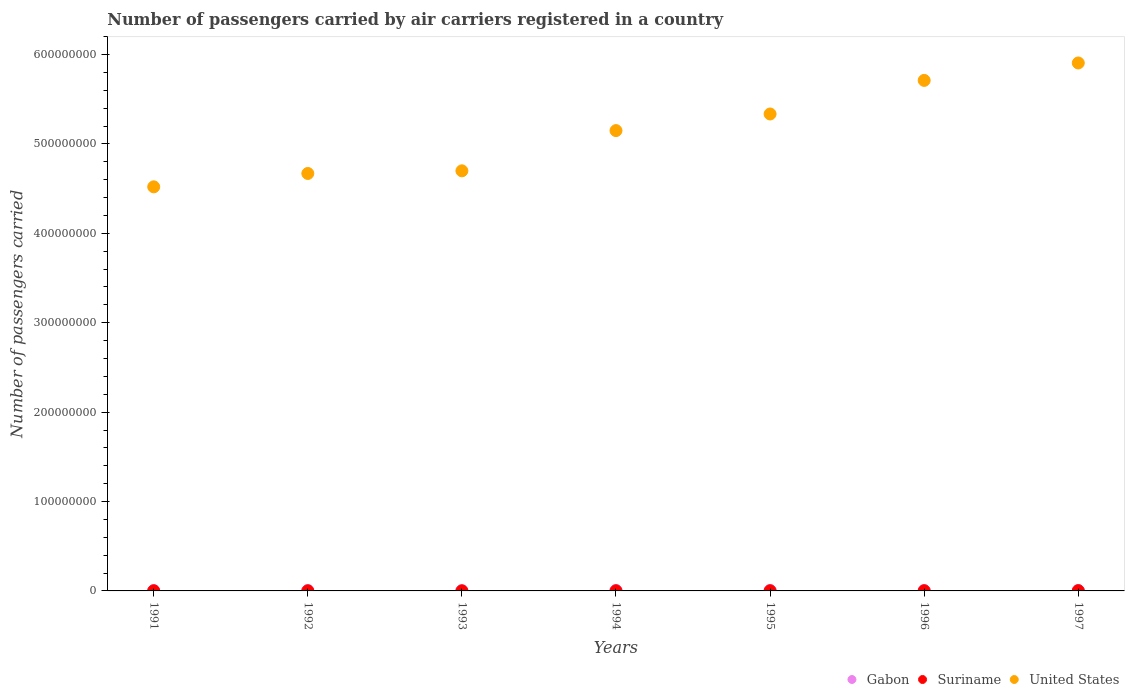Is the number of dotlines equal to the number of legend labels?
Your response must be concise. Yes. Across all years, what is the maximum number of passengers carried by air carriers in Gabon?
Provide a succinct answer. 5.08e+05. Across all years, what is the minimum number of passengers carried by air carriers in Gabon?
Your answer should be very brief. 3.02e+05. In which year was the number of passengers carried by air carriers in United States minimum?
Ensure brevity in your answer.  1991. What is the total number of passengers carried by air carriers in Suriname in the graph?
Your answer should be very brief. 1.15e+06. What is the difference between the number of passengers carried by air carriers in Gabon in 1992 and that in 1993?
Provide a short and direct response. 1.69e+05. What is the difference between the number of passengers carried by air carriers in Suriname in 1993 and the number of passengers carried by air carriers in United States in 1996?
Offer a terse response. -5.71e+08. What is the average number of passengers carried by air carriers in Gabon per year?
Make the answer very short. 4.46e+05. In the year 1996, what is the difference between the number of passengers carried by air carriers in Gabon and number of passengers carried by air carriers in Suriname?
Offer a terse response. 2.37e+05. What is the ratio of the number of passengers carried by air carriers in Suriname in 1991 to that in 1995?
Make the answer very short. 0.93. Is the difference between the number of passengers carried by air carriers in Gabon in 1991 and 1993 greater than the difference between the number of passengers carried by air carriers in Suriname in 1991 and 1993?
Give a very brief answer. Yes. What is the difference between the highest and the second highest number of passengers carried by air carriers in Suriname?
Give a very brief answer. 8.41e+04. What is the difference between the highest and the lowest number of passengers carried by air carriers in Gabon?
Keep it short and to the point. 2.06e+05. In how many years, is the number of passengers carried by air carriers in United States greater than the average number of passengers carried by air carriers in United States taken over all years?
Make the answer very short. 4. How many dotlines are there?
Ensure brevity in your answer.  3. Does the graph contain any zero values?
Ensure brevity in your answer.  No. Where does the legend appear in the graph?
Your answer should be compact. Bottom right. How many legend labels are there?
Your response must be concise. 3. How are the legend labels stacked?
Keep it short and to the point. Horizontal. What is the title of the graph?
Make the answer very short. Number of passengers carried by air carriers registered in a country. What is the label or title of the X-axis?
Ensure brevity in your answer.  Years. What is the label or title of the Y-axis?
Make the answer very short. Number of passengers carried. What is the Number of passengers carried of Gabon in 1991?
Keep it short and to the point. 4.36e+05. What is the Number of passengers carried in United States in 1991?
Make the answer very short. 4.52e+08. What is the Number of passengers carried in Gabon in 1992?
Make the answer very short. 4.71e+05. What is the Number of passengers carried in Suriname in 1992?
Offer a very short reply. 1.23e+05. What is the Number of passengers carried in United States in 1992?
Offer a very short reply. 4.67e+08. What is the Number of passengers carried in Gabon in 1993?
Make the answer very short. 3.02e+05. What is the Number of passengers carried in Suriname in 1993?
Your answer should be very brief. 9.60e+04. What is the Number of passengers carried in United States in 1993?
Provide a succinct answer. 4.70e+08. What is the Number of passengers carried of Gabon in 1994?
Your response must be concise. 5.05e+05. What is the Number of passengers carried in Suriname in 1994?
Ensure brevity in your answer.  1.49e+05. What is the Number of passengers carried of United States in 1994?
Provide a short and direct response. 5.15e+08. What is the Number of passengers carried of Gabon in 1995?
Provide a short and direct response. 5.08e+05. What is the Number of passengers carried in Suriname in 1995?
Ensure brevity in your answer.  1.62e+05. What is the Number of passengers carried of United States in 1995?
Offer a terse response. 5.34e+08. What is the Number of passengers carried of Gabon in 1996?
Keep it short and to the point. 4.31e+05. What is the Number of passengers carried in Suriname in 1996?
Your answer should be very brief. 1.95e+05. What is the Number of passengers carried of United States in 1996?
Your answer should be compact. 5.71e+08. What is the Number of passengers carried of Gabon in 1997?
Offer a very short reply. 4.68e+05. What is the Number of passengers carried of Suriname in 1997?
Offer a very short reply. 2.79e+05. What is the Number of passengers carried of United States in 1997?
Your response must be concise. 5.91e+08. Across all years, what is the maximum Number of passengers carried of Gabon?
Offer a terse response. 5.08e+05. Across all years, what is the maximum Number of passengers carried in Suriname?
Make the answer very short. 2.79e+05. Across all years, what is the maximum Number of passengers carried of United States?
Offer a very short reply. 5.91e+08. Across all years, what is the minimum Number of passengers carried in Gabon?
Offer a terse response. 3.02e+05. Across all years, what is the minimum Number of passengers carried of Suriname?
Provide a short and direct response. 9.60e+04. Across all years, what is the minimum Number of passengers carried in United States?
Offer a very short reply. 4.52e+08. What is the total Number of passengers carried of Gabon in the graph?
Keep it short and to the point. 3.12e+06. What is the total Number of passengers carried of Suriname in the graph?
Give a very brief answer. 1.15e+06. What is the total Number of passengers carried in United States in the graph?
Your response must be concise. 3.60e+09. What is the difference between the Number of passengers carried in Gabon in 1991 and that in 1992?
Keep it short and to the point. -3.54e+04. What is the difference between the Number of passengers carried in Suriname in 1991 and that in 1992?
Provide a short and direct response. 2.70e+04. What is the difference between the Number of passengers carried in United States in 1991 and that in 1992?
Ensure brevity in your answer.  -1.49e+07. What is the difference between the Number of passengers carried of Gabon in 1991 and that in 1993?
Your answer should be compact. 1.34e+05. What is the difference between the Number of passengers carried of Suriname in 1991 and that in 1993?
Provide a short and direct response. 5.40e+04. What is the difference between the Number of passengers carried in United States in 1991 and that in 1993?
Provide a short and direct response. -1.79e+07. What is the difference between the Number of passengers carried in Gabon in 1991 and that in 1994?
Give a very brief answer. -6.92e+04. What is the difference between the Number of passengers carried of Suriname in 1991 and that in 1994?
Your response must be concise. 1100. What is the difference between the Number of passengers carried in United States in 1991 and that in 1994?
Your answer should be very brief. -6.29e+07. What is the difference between the Number of passengers carried in Gabon in 1991 and that in 1995?
Offer a terse response. -7.22e+04. What is the difference between the Number of passengers carried in Suriname in 1991 and that in 1995?
Provide a succinct answer. -1.18e+04. What is the difference between the Number of passengers carried of United States in 1991 and that in 1995?
Make the answer very short. -8.15e+07. What is the difference between the Number of passengers carried of Gabon in 1991 and that in 1996?
Offer a terse response. 4700. What is the difference between the Number of passengers carried of Suriname in 1991 and that in 1996?
Provide a succinct answer. -4.47e+04. What is the difference between the Number of passengers carried in United States in 1991 and that in 1996?
Your answer should be compact. -1.19e+08. What is the difference between the Number of passengers carried of Gabon in 1991 and that in 1997?
Offer a very short reply. -3.25e+04. What is the difference between the Number of passengers carried of Suriname in 1991 and that in 1997?
Your answer should be very brief. -1.29e+05. What is the difference between the Number of passengers carried in United States in 1991 and that in 1997?
Offer a very short reply. -1.39e+08. What is the difference between the Number of passengers carried in Gabon in 1992 and that in 1993?
Offer a terse response. 1.69e+05. What is the difference between the Number of passengers carried in Suriname in 1992 and that in 1993?
Your response must be concise. 2.70e+04. What is the difference between the Number of passengers carried in United States in 1992 and that in 1993?
Offer a terse response. -2.96e+06. What is the difference between the Number of passengers carried of Gabon in 1992 and that in 1994?
Your response must be concise. -3.38e+04. What is the difference between the Number of passengers carried in Suriname in 1992 and that in 1994?
Give a very brief answer. -2.59e+04. What is the difference between the Number of passengers carried of United States in 1992 and that in 1994?
Give a very brief answer. -4.80e+07. What is the difference between the Number of passengers carried in Gabon in 1992 and that in 1995?
Make the answer very short. -3.68e+04. What is the difference between the Number of passengers carried of Suriname in 1992 and that in 1995?
Ensure brevity in your answer.  -3.88e+04. What is the difference between the Number of passengers carried of United States in 1992 and that in 1995?
Your answer should be compact. -6.65e+07. What is the difference between the Number of passengers carried of Gabon in 1992 and that in 1996?
Your response must be concise. 4.01e+04. What is the difference between the Number of passengers carried of Suriname in 1992 and that in 1996?
Provide a succinct answer. -7.17e+04. What is the difference between the Number of passengers carried in United States in 1992 and that in 1996?
Make the answer very short. -1.04e+08. What is the difference between the Number of passengers carried in Gabon in 1992 and that in 1997?
Offer a terse response. 2900. What is the difference between the Number of passengers carried of Suriname in 1992 and that in 1997?
Your answer should be compact. -1.56e+05. What is the difference between the Number of passengers carried of United States in 1992 and that in 1997?
Offer a very short reply. -1.24e+08. What is the difference between the Number of passengers carried in Gabon in 1993 and that in 1994?
Provide a succinct answer. -2.03e+05. What is the difference between the Number of passengers carried of Suriname in 1993 and that in 1994?
Your response must be concise. -5.29e+04. What is the difference between the Number of passengers carried of United States in 1993 and that in 1994?
Offer a terse response. -4.50e+07. What is the difference between the Number of passengers carried of Gabon in 1993 and that in 1995?
Provide a short and direct response. -2.06e+05. What is the difference between the Number of passengers carried in Suriname in 1993 and that in 1995?
Keep it short and to the point. -6.58e+04. What is the difference between the Number of passengers carried in United States in 1993 and that in 1995?
Make the answer very short. -6.36e+07. What is the difference between the Number of passengers carried in Gabon in 1993 and that in 1996?
Give a very brief answer. -1.29e+05. What is the difference between the Number of passengers carried in Suriname in 1993 and that in 1996?
Offer a very short reply. -9.87e+04. What is the difference between the Number of passengers carried in United States in 1993 and that in 1996?
Ensure brevity in your answer.  -1.01e+08. What is the difference between the Number of passengers carried in Gabon in 1993 and that in 1997?
Your answer should be compact. -1.66e+05. What is the difference between the Number of passengers carried of Suriname in 1993 and that in 1997?
Provide a short and direct response. -1.83e+05. What is the difference between the Number of passengers carried of United States in 1993 and that in 1997?
Ensure brevity in your answer.  -1.21e+08. What is the difference between the Number of passengers carried in Gabon in 1994 and that in 1995?
Your response must be concise. -3000. What is the difference between the Number of passengers carried in Suriname in 1994 and that in 1995?
Ensure brevity in your answer.  -1.29e+04. What is the difference between the Number of passengers carried of United States in 1994 and that in 1995?
Offer a terse response. -1.86e+07. What is the difference between the Number of passengers carried of Gabon in 1994 and that in 1996?
Your answer should be compact. 7.39e+04. What is the difference between the Number of passengers carried in Suriname in 1994 and that in 1996?
Provide a short and direct response. -4.58e+04. What is the difference between the Number of passengers carried in United States in 1994 and that in 1996?
Offer a terse response. -5.61e+07. What is the difference between the Number of passengers carried in Gabon in 1994 and that in 1997?
Keep it short and to the point. 3.67e+04. What is the difference between the Number of passengers carried in Suriname in 1994 and that in 1997?
Keep it short and to the point. -1.30e+05. What is the difference between the Number of passengers carried of United States in 1994 and that in 1997?
Your answer should be compact. -7.56e+07. What is the difference between the Number of passengers carried of Gabon in 1995 and that in 1996?
Your response must be concise. 7.69e+04. What is the difference between the Number of passengers carried in Suriname in 1995 and that in 1996?
Keep it short and to the point. -3.29e+04. What is the difference between the Number of passengers carried of United States in 1995 and that in 1996?
Your answer should be compact. -3.76e+07. What is the difference between the Number of passengers carried of Gabon in 1995 and that in 1997?
Keep it short and to the point. 3.97e+04. What is the difference between the Number of passengers carried of Suriname in 1995 and that in 1997?
Offer a terse response. -1.17e+05. What is the difference between the Number of passengers carried of United States in 1995 and that in 1997?
Keep it short and to the point. -5.71e+07. What is the difference between the Number of passengers carried of Gabon in 1996 and that in 1997?
Make the answer very short. -3.72e+04. What is the difference between the Number of passengers carried in Suriname in 1996 and that in 1997?
Offer a very short reply. -8.41e+04. What is the difference between the Number of passengers carried in United States in 1996 and that in 1997?
Offer a very short reply. -1.95e+07. What is the difference between the Number of passengers carried of Gabon in 1991 and the Number of passengers carried of Suriname in 1992?
Your answer should be very brief. 3.13e+05. What is the difference between the Number of passengers carried of Gabon in 1991 and the Number of passengers carried of United States in 1992?
Your response must be concise. -4.67e+08. What is the difference between the Number of passengers carried of Suriname in 1991 and the Number of passengers carried of United States in 1992?
Your answer should be compact. -4.67e+08. What is the difference between the Number of passengers carried in Gabon in 1991 and the Number of passengers carried in Suriname in 1993?
Give a very brief answer. 3.40e+05. What is the difference between the Number of passengers carried of Gabon in 1991 and the Number of passengers carried of United States in 1993?
Keep it short and to the point. -4.69e+08. What is the difference between the Number of passengers carried of Suriname in 1991 and the Number of passengers carried of United States in 1993?
Provide a short and direct response. -4.70e+08. What is the difference between the Number of passengers carried of Gabon in 1991 and the Number of passengers carried of Suriname in 1994?
Offer a very short reply. 2.87e+05. What is the difference between the Number of passengers carried of Gabon in 1991 and the Number of passengers carried of United States in 1994?
Provide a succinct answer. -5.14e+08. What is the difference between the Number of passengers carried in Suriname in 1991 and the Number of passengers carried in United States in 1994?
Make the answer very short. -5.15e+08. What is the difference between the Number of passengers carried in Gabon in 1991 and the Number of passengers carried in Suriname in 1995?
Keep it short and to the point. 2.74e+05. What is the difference between the Number of passengers carried in Gabon in 1991 and the Number of passengers carried in United States in 1995?
Give a very brief answer. -5.33e+08. What is the difference between the Number of passengers carried of Suriname in 1991 and the Number of passengers carried of United States in 1995?
Keep it short and to the point. -5.33e+08. What is the difference between the Number of passengers carried of Gabon in 1991 and the Number of passengers carried of Suriname in 1996?
Ensure brevity in your answer.  2.41e+05. What is the difference between the Number of passengers carried in Gabon in 1991 and the Number of passengers carried in United States in 1996?
Your answer should be compact. -5.71e+08. What is the difference between the Number of passengers carried of Suriname in 1991 and the Number of passengers carried of United States in 1996?
Keep it short and to the point. -5.71e+08. What is the difference between the Number of passengers carried in Gabon in 1991 and the Number of passengers carried in Suriname in 1997?
Give a very brief answer. 1.57e+05. What is the difference between the Number of passengers carried in Gabon in 1991 and the Number of passengers carried in United States in 1997?
Your response must be concise. -5.90e+08. What is the difference between the Number of passengers carried in Suriname in 1991 and the Number of passengers carried in United States in 1997?
Offer a terse response. -5.90e+08. What is the difference between the Number of passengers carried in Gabon in 1992 and the Number of passengers carried in Suriname in 1993?
Provide a succinct answer. 3.75e+05. What is the difference between the Number of passengers carried in Gabon in 1992 and the Number of passengers carried in United States in 1993?
Your answer should be very brief. -4.69e+08. What is the difference between the Number of passengers carried of Suriname in 1992 and the Number of passengers carried of United States in 1993?
Offer a very short reply. -4.70e+08. What is the difference between the Number of passengers carried of Gabon in 1992 and the Number of passengers carried of Suriname in 1994?
Offer a very short reply. 3.22e+05. What is the difference between the Number of passengers carried of Gabon in 1992 and the Number of passengers carried of United States in 1994?
Give a very brief answer. -5.14e+08. What is the difference between the Number of passengers carried of Suriname in 1992 and the Number of passengers carried of United States in 1994?
Make the answer very short. -5.15e+08. What is the difference between the Number of passengers carried in Gabon in 1992 and the Number of passengers carried in Suriname in 1995?
Offer a terse response. 3.10e+05. What is the difference between the Number of passengers carried of Gabon in 1992 and the Number of passengers carried of United States in 1995?
Offer a terse response. -5.33e+08. What is the difference between the Number of passengers carried in Suriname in 1992 and the Number of passengers carried in United States in 1995?
Offer a very short reply. -5.33e+08. What is the difference between the Number of passengers carried of Gabon in 1992 and the Number of passengers carried of Suriname in 1996?
Your response must be concise. 2.77e+05. What is the difference between the Number of passengers carried of Gabon in 1992 and the Number of passengers carried of United States in 1996?
Make the answer very short. -5.71e+08. What is the difference between the Number of passengers carried of Suriname in 1992 and the Number of passengers carried of United States in 1996?
Offer a very short reply. -5.71e+08. What is the difference between the Number of passengers carried in Gabon in 1992 and the Number of passengers carried in Suriname in 1997?
Your answer should be very brief. 1.93e+05. What is the difference between the Number of passengers carried of Gabon in 1992 and the Number of passengers carried of United States in 1997?
Your answer should be compact. -5.90e+08. What is the difference between the Number of passengers carried in Suriname in 1992 and the Number of passengers carried in United States in 1997?
Give a very brief answer. -5.90e+08. What is the difference between the Number of passengers carried in Gabon in 1993 and the Number of passengers carried in Suriname in 1994?
Make the answer very short. 1.53e+05. What is the difference between the Number of passengers carried in Gabon in 1993 and the Number of passengers carried in United States in 1994?
Offer a very short reply. -5.15e+08. What is the difference between the Number of passengers carried of Suriname in 1993 and the Number of passengers carried of United States in 1994?
Offer a very short reply. -5.15e+08. What is the difference between the Number of passengers carried of Gabon in 1993 and the Number of passengers carried of Suriname in 1995?
Keep it short and to the point. 1.40e+05. What is the difference between the Number of passengers carried in Gabon in 1993 and the Number of passengers carried in United States in 1995?
Ensure brevity in your answer.  -5.33e+08. What is the difference between the Number of passengers carried of Suriname in 1993 and the Number of passengers carried of United States in 1995?
Your answer should be compact. -5.33e+08. What is the difference between the Number of passengers carried of Gabon in 1993 and the Number of passengers carried of Suriname in 1996?
Your answer should be very brief. 1.08e+05. What is the difference between the Number of passengers carried of Gabon in 1993 and the Number of passengers carried of United States in 1996?
Make the answer very short. -5.71e+08. What is the difference between the Number of passengers carried of Suriname in 1993 and the Number of passengers carried of United States in 1996?
Ensure brevity in your answer.  -5.71e+08. What is the difference between the Number of passengers carried in Gabon in 1993 and the Number of passengers carried in Suriname in 1997?
Provide a succinct answer. 2.35e+04. What is the difference between the Number of passengers carried in Gabon in 1993 and the Number of passengers carried in United States in 1997?
Your answer should be compact. -5.90e+08. What is the difference between the Number of passengers carried in Suriname in 1993 and the Number of passengers carried in United States in 1997?
Provide a short and direct response. -5.90e+08. What is the difference between the Number of passengers carried of Gabon in 1994 and the Number of passengers carried of Suriname in 1995?
Keep it short and to the point. 3.43e+05. What is the difference between the Number of passengers carried of Gabon in 1994 and the Number of passengers carried of United States in 1995?
Offer a very short reply. -5.33e+08. What is the difference between the Number of passengers carried of Suriname in 1994 and the Number of passengers carried of United States in 1995?
Your answer should be compact. -5.33e+08. What is the difference between the Number of passengers carried in Gabon in 1994 and the Number of passengers carried in Suriname in 1996?
Keep it short and to the point. 3.10e+05. What is the difference between the Number of passengers carried in Gabon in 1994 and the Number of passengers carried in United States in 1996?
Your answer should be compact. -5.71e+08. What is the difference between the Number of passengers carried of Suriname in 1994 and the Number of passengers carried of United States in 1996?
Your answer should be compact. -5.71e+08. What is the difference between the Number of passengers carried of Gabon in 1994 and the Number of passengers carried of Suriname in 1997?
Offer a very short reply. 2.26e+05. What is the difference between the Number of passengers carried of Gabon in 1994 and the Number of passengers carried of United States in 1997?
Your answer should be very brief. -5.90e+08. What is the difference between the Number of passengers carried in Suriname in 1994 and the Number of passengers carried in United States in 1997?
Your response must be concise. -5.90e+08. What is the difference between the Number of passengers carried of Gabon in 1995 and the Number of passengers carried of Suriname in 1996?
Offer a terse response. 3.14e+05. What is the difference between the Number of passengers carried in Gabon in 1995 and the Number of passengers carried in United States in 1996?
Ensure brevity in your answer.  -5.71e+08. What is the difference between the Number of passengers carried in Suriname in 1995 and the Number of passengers carried in United States in 1996?
Make the answer very short. -5.71e+08. What is the difference between the Number of passengers carried of Gabon in 1995 and the Number of passengers carried of Suriname in 1997?
Ensure brevity in your answer.  2.29e+05. What is the difference between the Number of passengers carried in Gabon in 1995 and the Number of passengers carried in United States in 1997?
Offer a terse response. -5.90e+08. What is the difference between the Number of passengers carried of Suriname in 1995 and the Number of passengers carried of United States in 1997?
Provide a short and direct response. -5.90e+08. What is the difference between the Number of passengers carried in Gabon in 1996 and the Number of passengers carried in Suriname in 1997?
Offer a very short reply. 1.52e+05. What is the difference between the Number of passengers carried of Gabon in 1996 and the Number of passengers carried of United States in 1997?
Your answer should be compact. -5.90e+08. What is the difference between the Number of passengers carried in Suriname in 1996 and the Number of passengers carried in United States in 1997?
Your answer should be compact. -5.90e+08. What is the average Number of passengers carried in Gabon per year?
Your response must be concise. 4.46e+05. What is the average Number of passengers carried in Suriname per year?
Give a very brief answer. 1.65e+05. What is the average Number of passengers carried in United States per year?
Ensure brevity in your answer.  5.14e+08. In the year 1991, what is the difference between the Number of passengers carried of Gabon and Number of passengers carried of Suriname?
Provide a succinct answer. 2.86e+05. In the year 1991, what is the difference between the Number of passengers carried of Gabon and Number of passengers carried of United States?
Your response must be concise. -4.52e+08. In the year 1991, what is the difference between the Number of passengers carried in Suriname and Number of passengers carried in United States?
Make the answer very short. -4.52e+08. In the year 1992, what is the difference between the Number of passengers carried of Gabon and Number of passengers carried of Suriname?
Make the answer very short. 3.48e+05. In the year 1992, what is the difference between the Number of passengers carried in Gabon and Number of passengers carried in United States?
Provide a short and direct response. -4.66e+08. In the year 1992, what is the difference between the Number of passengers carried in Suriname and Number of passengers carried in United States?
Your response must be concise. -4.67e+08. In the year 1993, what is the difference between the Number of passengers carried of Gabon and Number of passengers carried of Suriname?
Give a very brief answer. 2.06e+05. In the year 1993, what is the difference between the Number of passengers carried in Gabon and Number of passengers carried in United States?
Your answer should be very brief. -4.70e+08. In the year 1993, what is the difference between the Number of passengers carried of Suriname and Number of passengers carried of United States?
Make the answer very short. -4.70e+08. In the year 1994, what is the difference between the Number of passengers carried in Gabon and Number of passengers carried in Suriname?
Your answer should be very brief. 3.56e+05. In the year 1994, what is the difference between the Number of passengers carried in Gabon and Number of passengers carried in United States?
Offer a very short reply. -5.14e+08. In the year 1994, what is the difference between the Number of passengers carried in Suriname and Number of passengers carried in United States?
Provide a succinct answer. -5.15e+08. In the year 1995, what is the difference between the Number of passengers carried of Gabon and Number of passengers carried of Suriname?
Ensure brevity in your answer.  3.46e+05. In the year 1995, what is the difference between the Number of passengers carried of Gabon and Number of passengers carried of United States?
Offer a very short reply. -5.33e+08. In the year 1995, what is the difference between the Number of passengers carried in Suriname and Number of passengers carried in United States?
Offer a very short reply. -5.33e+08. In the year 1996, what is the difference between the Number of passengers carried of Gabon and Number of passengers carried of Suriname?
Give a very brief answer. 2.37e+05. In the year 1996, what is the difference between the Number of passengers carried in Gabon and Number of passengers carried in United States?
Your response must be concise. -5.71e+08. In the year 1996, what is the difference between the Number of passengers carried in Suriname and Number of passengers carried in United States?
Your answer should be very brief. -5.71e+08. In the year 1997, what is the difference between the Number of passengers carried in Gabon and Number of passengers carried in Suriname?
Keep it short and to the point. 1.90e+05. In the year 1997, what is the difference between the Number of passengers carried in Gabon and Number of passengers carried in United States?
Ensure brevity in your answer.  -5.90e+08. In the year 1997, what is the difference between the Number of passengers carried in Suriname and Number of passengers carried in United States?
Your answer should be compact. -5.90e+08. What is the ratio of the Number of passengers carried of Gabon in 1991 to that in 1992?
Your response must be concise. 0.92. What is the ratio of the Number of passengers carried in Suriname in 1991 to that in 1992?
Make the answer very short. 1.22. What is the ratio of the Number of passengers carried in Gabon in 1991 to that in 1993?
Keep it short and to the point. 1.44. What is the ratio of the Number of passengers carried of Suriname in 1991 to that in 1993?
Provide a short and direct response. 1.56. What is the ratio of the Number of passengers carried in United States in 1991 to that in 1993?
Provide a short and direct response. 0.96. What is the ratio of the Number of passengers carried of Gabon in 1991 to that in 1994?
Your response must be concise. 0.86. What is the ratio of the Number of passengers carried in Suriname in 1991 to that in 1994?
Provide a succinct answer. 1.01. What is the ratio of the Number of passengers carried in United States in 1991 to that in 1994?
Provide a succinct answer. 0.88. What is the ratio of the Number of passengers carried in Gabon in 1991 to that in 1995?
Your answer should be very brief. 0.86. What is the ratio of the Number of passengers carried in Suriname in 1991 to that in 1995?
Give a very brief answer. 0.93. What is the ratio of the Number of passengers carried in United States in 1991 to that in 1995?
Provide a short and direct response. 0.85. What is the ratio of the Number of passengers carried in Gabon in 1991 to that in 1996?
Provide a succinct answer. 1.01. What is the ratio of the Number of passengers carried of Suriname in 1991 to that in 1996?
Your answer should be compact. 0.77. What is the ratio of the Number of passengers carried in United States in 1991 to that in 1996?
Your answer should be compact. 0.79. What is the ratio of the Number of passengers carried in Gabon in 1991 to that in 1997?
Offer a terse response. 0.93. What is the ratio of the Number of passengers carried of Suriname in 1991 to that in 1997?
Ensure brevity in your answer.  0.54. What is the ratio of the Number of passengers carried in United States in 1991 to that in 1997?
Your response must be concise. 0.77. What is the ratio of the Number of passengers carried of Gabon in 1992 to that in 1993?
Your answer should be compact. 1.56. What is the ratio of the Number of passengers carried in Suriname in 1992 to that in 1993?
Make the answer very short. 1.28. What is the ratio of the Number of passengers carried of Gabon in 1992 to that in 1994?
Your answer should be very brief. 0.93. What is the ratio of the Number of passengers carried in Suriname in 1992 to that in 1994?
Your answer should be very brief. 0.83. What is the ratio of the Number of passengers carried in United States in 1992 to that in 1994?
Ensure brevity in your answer.  0.91. What is the ratio of the Number of passengers carried of Gabon in 1992 to that in 1995?
Offer a terse response. 0.93. What is the ratio of the Number of passengers carried in Suriname in 1992 to that in 1995?
Your response must be concise. 0.76. What is the ratio of the Number of passengers carried of United States in 1992 to that in 1995?
Provide a succinct answer. 0.88. What is the ratio of the Number of passengers carried of Gabon in 1992 to that in 1996?
Your answer should be compact. 1.09. What is the ratio of the Number of passengers carried of Suriname in 1992 to that in 1996?
Provide a succinct answer. 0.63. What is the ratio of the Number of passengers carried in United States in 1992 to that in 1996?
Keep it short and to the point. 0.82. What is the ratio of the Number of passengers carried of Suriname in 1992 to that in 1997?
Provide a short and direct response. 0.44. What is the ratio of the Number of passengers carried of United States in 1992 to that in 1997?
Make the answer very short. 0.79. What is the ratio of the Number of passengers carried in Gabon in 1993 to that in 1994?
Offer a terse response. 0.6. What is the ratio of the Number of passengers carried of Suriname in 1993 to that in 1994?
Ensure brevity in your answer.  0.64. What is the ratio of the Number of passengers carried in United States in 1993 to that in 1994?
Give a very brief answer. 0.91. What is the ratio of the Number of passengers carried in Gabon in 1993 to that in 1995?
Provide a succinct answer. 0.59. What is the ratio of the Number of passengers carried of Suriname in 1993 to that in 1995?
Offer a very short reply. 0.59. What is the ratio of the Number of passengers carried in United States in 1993 to that in 1995?
Ensure brevity in your answer.  0.88. What is the ratio of the Number of passengers carried of Gabon in 1993 to that in 1996?
Give a very brief answer. 0.7. What is the ratio of the Number of passengers carried of Suriname in 1993 to that in 1996?
Provide a short and direct response. 0.49. What is the ratio of the Number of passengers carried in United States in 1993 to that in 1996?
Offer a terse response. 0.82. What is the ratio of the Number of passengers carried of Gabon in 1993 to that in 1997?
Keep it short and to the point. 0.65. What is the ratio of the Number of passengers carried of Suriname in 1993 to that in 1997?
Give a very brief answer. 0.34. What is the ratio of the Number of passengers carried of United States in 1993 to that in 1997?
Offer a very short reply. 0.8. What is the ratio of the Number of passengers carried in Suriname in 1994 to that in 1995?
Offer a very short reply. 0.92. What is the ratio of the Number of passengers carried of United States in 1994 to that in 1995?
Make the answer very short. 0.97. What is the ratio of the Number of passengers carried in Gabon in 1994 to that in 1996?
Make the answer very short. 1.17. What is the ratio of the Number of passengers carried of Suriname in 1994 to that in 1996?
Provide a succinct answer. 0.76. What is the ratio of the Number of passengers carried of United States in 1994 to that in 1996?
Your response must be concise. 0.9. What is the ratio of the Number of passengers carried in Gabon in 1994 to that in 1997?
Your answer should be compact. 1.08. What is the ratio of the Number of passengers carried of Suriname in 1994 to that in 1997?
Keep it short and to the point. 0.53. What is the ratio of the Number of passengers carried in United States in 1994 to that in 1997?
Ensure brevity in your answer.  0.87. What is the ratio of the Number of passengers carried in Gabon in 1995 to that in 1996?
Your response must be concise. 1.18. What is the ratio of the Number of passengers carried of Suriname in 1995 to that in 1996?
Provide a succinct answer. 0.83. What is the ratio of the Number of passengers carried in United States in 1995 to that in 1996?
Ensure brevity in your answer.  0.93. What is the ratio of the Number of passengers carried of Gabon in 1995 to that in 1997?
Offer a terse response. 1.08. What is the ratio of the Number of passengers carried in Suriname in 1995 to that in 1997?
Your answer should be very brief. 0.58. What is the ratio of the Number of passengers carried of United States in 1995 to that in 1997?
Make the answer very short. 0.9. What is the ratio of the Number of passengers carried of Gabon in 1996 to that in 1997?
Ensure brevity in your answer.  0.92. What is the ratio of the Number of passengers carried in Suriname in 1996 to that in 1997?
Your answer should be very brief. 0.7. What is the difference between the highest and the second highest Number of passengers carried of Gabon?
Ensure brevity in your answer.  3000. What is the difference between the highest and the second highest Number of passengers carried of Suriname?
Your response must be concise. 8.41e+04. What is the difference between the highest and the second highest Number of passengers carried of United States?
Provide a succinct answer. 1.95e+07. What is the difference between the highest and the lowest Number of passengers carried in Gabon?
Offer a very short reply. 2.06e+05. What is the difference between the highest and the lowest Number of passengers carried in Suriname?
Provide a succinct answer. 1.83e+05. What is the difference between the highest and the lowest Number of passengers carried of United States?
Provide a short and direct response. 1.39e+08. 